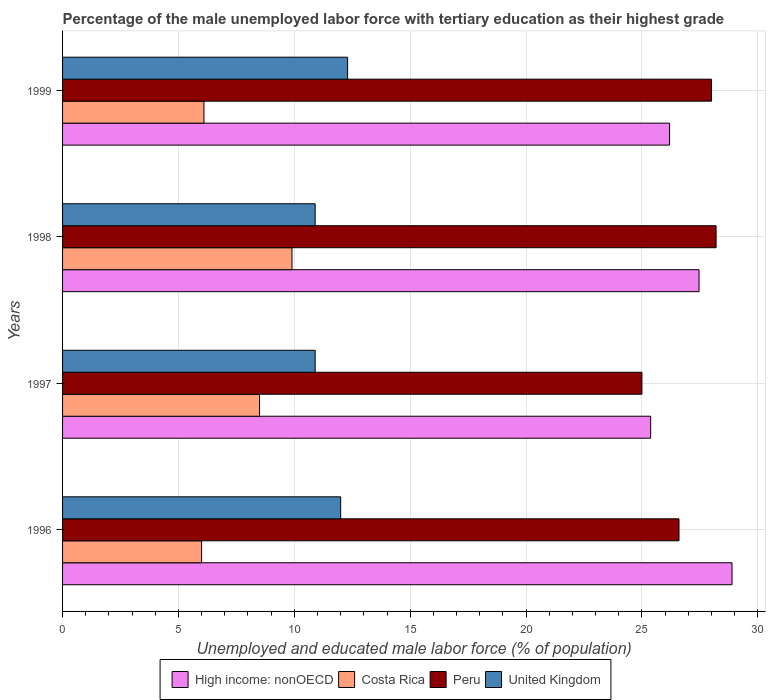How many different coloured bars are there?
Your response must be concise. 4. What is the label of the 1st group of bars from the top?
Offer a very short reply. 1999. In how many cases, is the number of bars for a given year not equal to the number of legend labels?
Your answer should be very brief. 0. What is the percentage of the unemployed male labor force with tertiary education in Costa Rica in 1999?
Give a very brief answer. 6.1. Across all years, what is the maximum percentage of the unemployed male labor force with tertiary education in United Kingdom?
Your response must be concise. 12.3. Across all years, what is the minimum percentage of the unemployed male labor force with tertiary education in United Kingdom?
Make the answer very short. 10.9. In which year was the percentage of the unemployed male labor force with tertiary education in High income: nonOECD maximum?
Make the answer very short. 1996. In which year was the percentage of the unemployed male labor force with tertiary education in Costa Rica minimum?
Offer a very short reply. 1996. What is the total percentage of the unemployed male labor force with tertiary education in High income: nonOECD in the graph?
Your response must be concise. 107.92. What is the difference between the percentage of the unemployed male labor force with tertiary education in Peru in 1998 and that in 1999?
Your answer should be compact. 0.2. What is the difference between the percentage of the unemployed male labor force with tertiary education in Peru in 1996 and the percentage of the unemployed male labor force with tertiary education in United Kingdom in 1998?
Provide a succinct answer. 15.7. What is the average percentage of the unemployed male labor force with tertiary education in High income: nonOECD per year?
Your response must be concise. 26.98. In the year 1997, what is the difference between the percentage of the unemployed male labor force with tertiary education in High income: nonOECD and percentage of the unemployed male labor force with tertiary education in United Kingdom?
Provide a short and direct response. 14.48. In how many years, is the percentage of the unemployed male labor force with tertiary education in Peru greater than 1 %?
Your response must be concise. 4. What is the ratio of the percentage of the unemployed male labor force with tertiary education in High income: nonOECD in 1996 to that in 1997?
Your answer should be compact. 1.14. Is the percentage of the unemployed male labor force with tertiary education in United Kingdom in 1996 less than that in 1997?
Your answer should be compact. No. Is the difference between the percentage of the unemployed male labor force with tertiary education in High income: nonOECD in 1996 and 1998 greater than the difference between the percentage of the unemployed male labor force with tertiary education in United Kingdom in 1996 and 1998?
Provide a succinct answer. Yes. What is the difference between the highest and the second highest percentage of the unemployed male labor force with tertiary education in High income: nonOECD?
Your response must be concise. 1.42. What is the difference between the highest and the lowest percentage of the unemployed male labor force with tertiary education in United Kingdom?
Provide a succinct answer. 1.4. Is the sum of the percentage of the unemployed male labor force with tertiary education in High income: nonOECD in 1997 and 1998 greater than the maximum percentage of the unemployed male labor force with tertiary education in United Kingdom across all years?
Offer a terse response. Yes. What does the 3rd bar from the top in 1997 represents?
Your answer should be very brief. Costa Rica. How many bars are there?
Offer a very short reply. 16. How many years are there in the graph?
Offer a terse response. 4. Does the graph contain any zero values?
Ensure brevity in your answer.  No. How many legend labels are there?
Give a very brief answer. 4. What is the title of the graph?
Provide a succinct answer. Percentage of the male unemployed labor force with tertiary education as their highest grade. What is the label or title of the X-axis?
Your response must be concise. Unemployed and educated male labor force (% of population). What is the label or title of the Y-axis?
Give a very brief answer. Years. What is the Unemployed and educated male labor force (% of population) in High income: nonOECD in 1996?
Ensure brevity in your answer.  28.89. What is the Unemployed and educated male labor force (% of population) in Costa Rica in 1996?
Give a very brief answer. 6. What is the Unemployed and educated male labor force (% of population) of Peru in 1996?
Offer a very short reply. 26.6. What is the Unemployed and educated male labor force (% of population) of United Kingdom in 1996?
Ensure brevity in your answer.  12. What is the Unemployed and educated male labor force (% of population) of High income: nonOECD in 1997?
Give a very brief answer. 25.38. What is the Unemployed and educated male labor force (% of population) in United Kingdom in 1997?
Your answer should be very brief. 10.9. What is the Unemployed and educated male labor force (% of population) in High income: nonOECD in 1998?
Provide a succinct answer. 27.46. What is the Unemployed and educated male labor force (% of population) in Costa Rica in 1998?
Your response must be concise. 9.9. What is the Unemployed and educated male labor force (% of population) of Peru in 1998?
Ensure brevity in your answer.  28.2. What is the Unemployed and educated male labor force (% of population) in United Kingdom in 1998?
Provide a short and direct response. 10.9. What is the Unemployed and educated male labor force (% of population) of High income: nonOECD in 1999?
Make the answer very short. 26.19. What is the Unemployed and educated male labor force (% of population) of Costa Rica in 1999?
Your answer should be very brief. 6.1. What is the Unemployed and educated male labor force (% of population) of Peru in 1999?
Offer a very short reply. 28. What is the Unemployed and educated male labor force (% of population) in United Kingdom in 1999?
Keep it short and to the point. 12.3. Across all years, what is the maximum Unemployed and educated male labor force (% of population) of High income: nonOECD?
Your answer should be very brief. 28.89. Across all years, what is the maximum Unemployed and educated male labor force (% of population) of Costa Rica?
Ensure brevity in your answer.  9.9. Across all years, what is the maximum Unemployed and educated male labor force (% of population) in Peru?
Make the answer very short. 28.2. Across all years, what is the maximum Unemployed and educated male labor force (% of population) of United Kingdom?
Offer a terse response. 12.3. Across all years, what is the minimum Unemployed and educated male labor force (% of population) of High income: nonOECD?
Give a very brief answer. 25.38. Across all years, what is the minimum Unemployed and educated male labor force (% of population) of Peru?
Offer a very short reply. 25. Across all years, what is the minimum Unemployed and educated male labor force (% of population) in United Kingdom?
Provide a succinct answer. 10.9. What is the total Unemployed and educated male labor force (% of population) in High income: nonOECD in the graph?
Your answer should be very brief. 107.92. What is the total Unemployed and educated male labor force (% of population) in Costa Rica in the graph?
Provide a succinct answer. 30.5. What is the total Unemployed and educated male labor force (% of population) in Peru in the graph?
Make the answer very short. 107.8. What is the total Unemployed and educated male labor force (% of population) in United Kingdom in the graph?
Keep it short and to the point. 46.1. What is the difference between the Unemployed and educated male labor force (% of population) in High income: nonOECD in 1996 and that in 1997?
Your answer should be very brief. 3.51. What is the difference between the Unemployed and educated male labor force (% of population) in Costa Rica in 1996 and that in 1997?
Your response must be concise. -2.5. What is the difference between the Unemployed and educated male labor force (% of population) in Peru in 1996 and that in 1997?
Make the answer very short. 1.6. What is the difference between the Unemployed and educated male labor force (% of population) of High income: nonOECD in 1996 and that in 1998?
Keep it short and to the point. 1.42. What is the difference between the Unemployed and educated male labor force (% of population) of Costa Rica in 1996 and that in 1998?
Your answer should be compact. -3.9. What is the difference between the Unemployed and educated male labor force (% of population) in High income: nonOECD in 1996 and that in 1999?
Give a very brief answer. 2.69. What is the difference between the Unemployed and educated male labor force (% of population) of Costa Rica in 1996 and that in 1999?
Make the answer very short. -0.1. What is the difference between the Unemployed and educated male labor force (% of population) in Peru in 1996 and that in 1999?
Make the answer very short. -1.4. What is the difference between the Unemployed and educated male labor force (% of population) of High income: nonOECD in 1997 and that in 1998?
Provide a short and direct response. -2.09. What is the difference between the Unemployed and educated male labor force (% of population) of Costa Rica in 1997 and that in 1998?
Your answer should be compact. -1.4. What is the difference between the Unemployed and educated male labor force (% of population) of High income: nonOECD in 1997 and that in 1999?
Keep it short and to the point. -0.82. What is the difference between the Unemployed and educated male labor force (% of population) of Peru in 1997 and that in 1999?
Provide a succinct answer. -3. What is the difference between the Unemployed and educated male labor force (% of population) in United Kingdom in 1997 and that in 1999?
Your answer should be very brief. -1.4. What is the difference between the Unemployed and educated male labor force (% of population) in High income: nonOECD in 1998 and that in 1999?
Provide a succinct answer. 1.27. What is the difference between the Unemployed and educated male labor force (% of population) in Costa Rica in 1998 and that in 1999?
Give a very brief answer. 3.8. What is the difference between the Unemployed and educated male labor force (% of population) of United Kingdom in 1998 and that in 1999?
Give a very brief answer. -1.4. What is the difference between the Unemployed and educated male labor force (% of population) in High income: nonOECD in 1996 and the Unemployed and educated male labor force (% of population) in Costa Rica in 1997?
Your answer should be very brief. 20.39. What is the difference between the Unemployed and educated male labor force (% of population) of High income: nonOECD in 1996 and the Unemployed and educated male labor force (% of population) of Peru in 1997?
Provide a succinct answer. 3.89. What is the difference between the Unemployed and educated male labor force (% of population) of High income: nonOECD in 1996 and the Unemployed and educated male labor force (% of population) of United Kingdom in 1997?
Offer a terse response. 17.99. What is the difference between the Unemployed and educated male labor force (% of population) of Costa Rica in 1996 and the Unemployed and educated male labor force (% of population) of Peru in 1997?
Provide a short and direct response. -19. What is the difference between the Unemployed and educated male labor force (% of population) in High income: nonOECD in 1996 and the Unemployed and educated male labor force (% of population) in Costa Rica in 1998?
Make the answer very short. 18.99. What is the difference between the Unemployed and educated male labor force (% of population) in High income: nonOECD in 1996 and the Unemployed and educated male labor force (% of population) in Peru in 1998?
Provide a short and direct response. 0.69. What is the difference between the Unemployed and educated male labor force (% of population) of High income: nonOECD in 1996 and the Unemployed and educated male labor force (% of population) of United Kingdom in 1998?
Keep it short and to the point. 17.99. What is the difference between the Unemployed and educated male labor force (% of population) of Costa Rica in 1996 and the Unemployed and educated male labor force (% of population) of Peru in 1998?
Your response must be concise. -22.2. What is the difference between the Unemployed and educated male labor force (% of population) of Costa Rica in 1996 and the Unemployed and educated male labor force (% of population) of United Kingdom in 1998?
Provide a short and direct response. -4.9. What is the difference between the Unemployed and educated male labor force (% of population) of High income: nonOECD in 1996 and the Unemployed and educated male labor force (% of population) of Costa Rica in 1999?
Your answer should be compact. 22.79. What is the difference between the Unemployed and educated male labor force (% of population) in High income: nonOECD in 1996 and the Unemployed and educated male labor force (% of population) in Peru in 1999?
Provide a succinct answer. 0.89. What is the difference between the Unemployed and educated male labor force (% of population) in High income: nonOECD in 1996 and the Unemployed and educated male labor force (% of population) in United Kingdom in 1999?
Provide a succinct answer. 16.59. What is the difference between the Unemployed and educated male labor force (% of population) in Costa Rica in 1996 and the Unemployed and educated male labor force (% of population) in Peru in 1999?
Your answer should be compact. -22. What is the difference between the Unemployed and educated male labor force (% of population) in Costa Rica in 1996 and the Unemployed and educated male labor force (% of population) in United Kingdom in 1999?
Your answer should be compact. -6.3. What is the difference between the Unemployed and educated male labor force (% of population) in High income: nonOECD in 1997 and the Unemployed and educated male labor force (% of population) in Costa Rica in 1998?
Offer a very short reply. 15.48. What is the difference between the Unemployed and educated male labor force (% of population) of High income: nonOECD in 1997 and the Unemployed and educated male labor force (% of population) of Peru in 1998?
Give a very brief answer. -2.82. What is the difference between the Unemployed and educated male labor force (% of population) of High income: nonOECD in 1997 and the Unemployed and educated male labor force (% of population) of United Kingdom in 1998?
Make the answer very short. 14.48. What is the difference between the Unemployed and educated male labor force (% of population) of Costa Rica in 1997 and the Unemployed and educated male labor force (% of population) of Peru in 1998?
Offer a terse response. -19.7. What is the difference between the Unemployed and educated male labor force (% of population) in High income: nonOECD in 1997 and the Unemployed and educated male labor force (% of population) in Costa Rica in 1999?
Provide a short and direct response. 19.28. What is the difference between the Unemployed and educated male labor force (% of population) of High income: nonOECD in 1997 and the Unemployed and educated male labor force (% of population) of Peru in 1999?
Ensure brevity in your answer.  -2.62. What is the difference between the Unemployed and educated male labor force (% of population) in High income: nonOECD in 1997 and the Unemployed and educated male labor force (% of population) in United Kingdom in 1999?
Your answer should be very brief. 13.08. What is the difference between the Unemployed and educated male labor force (% of population) in Costa Rica in 1997 and the Unemployed and educated male labor force (% of population) in Peru in 1999?
Offer a terse response. -19.5. What is the difference between the Unemployed and educated male labor force (% of population) of Peru in 1997 and the Unemployed and educated male labor force (% of population) of United Kingdom in 1999?
Offer a very short reply. 12.7. What is the difference between the Unemployed and educated male labor force (% of population) of High income: nonOECD in 1998 and the Unemployed and educated male labor force (% of population) of Costa Rica in 1999?
Your response must be concise. 21.36. What is the difference between the Unemployed and educated male labor force (% of population) in High income: nonOECD in 1998 and the Unemployed and educated male labor force (% of population) in Peru in 1999?
Your response must be concise. -0.54. What is the difference between the Unemployed and educated male labor force (% of population) in High income: nonOECD in 1998 and the Unemployed and educated male labor force (% of population) in United Kingdom in 1999?
Provide a succinct answer. 15.16. What is the difference between the Unemployed and educated male labor force (% of population) in Costa Rica in 1998 and the Unemployed and educated male labor force (% of population) in Peru in 1999?
Give a very brief answer. -18.1. What is the difference between the Unemployed and educated male labor force (% of population) in Costa Rica in 1998 and the Unemployed and educated male labor force (% of population) in United Kingdom in 1999?
Your answer should be compact. -2.4. What is the average Unemployed and educated male labor force (% of population) of High income: nonOECD per year?
Offer a terse response. 26.98. What is the average Unemployed and educated male labor force (% of population) of Costa Rica per year?
Your answer should be compact. 7.62. What is the average Unemployed and educated male labor force (% of population) of Peru per year?
Offer a very short reply. 26.95. What is the average Unemployed and educated male labor force (% of population) of United Kingdom per year?
Your response must be concise. 11.53. In the year 1996, what is the difference between the Unemployed and educated male labor force (% of population) in High income: nonOECD and Unemployed and educated male labor force (% of population) in Costa Rica?
Your answer should be very brief. 22.89. In the year 1996, what is the difference between the Unemployed and educated male labor force (% of population) of High income: nonOECD and Unemployed and educated male labor force (% of population) of Peru?
Your answer should be compact. 2.29. In the year 1996, what is the difference between the Unemployed and educated male labor force (% of population) of High income: nonOECD and Unemployed and educated male labor force (% of population) of United Kingdom?
Ensure brevity in your answer.  16.89. In the year 1996, what is the difference between the Unemployed and educated male labor force (% of population) of Costa Rica and Unemployed and educated male labor force (% of population) of Peru?
Your answer should be very brief. -20.6. In the year 1996, what is the difference between the Unemployed and educated male labor force (% of population) in Costa Rica and Unemployed and educated male labor force (% of population) in United Kingdom?
Offer a terse response. -6. In the year 1996, what is the difference between the Unemployed and educated male labor force (% of population) of Peru and Unemployed and educated male labor force (% of population) of United Kingdom?
Offer a terse response. 14.6. In the year 1997, what is the difference between the Unemployed and educated male labor force (% of population) in High income: nonOECD and Unemployed and educated male labor force (% of population) in Costa Rica?
Provide a short and direct response. 16.88. In the year 1997, what is the difference between the Unemployed and educated male labor force (% of population) in High income: nonOECD and Unemployed and educated male labor force (% of population) in Peru?
Your answer should be very brief. 0.38. In the year 1997, what is the difference between the Unemployed and educated male labor force (% of population) of High income: nonOECD and Unemployed and educated male labor force (% of population) of United Kingdom?
Offer a very short reply. 14.48. In the year 1997, what is the difference between the Unemployed and educated male labor force (% of population) of Costa Rica and Unemployed and educated male labor force (% of population) of Peru?
Provide a short and direct response. -16.5. In the year 1997, what is the difference between the Unemployed and educated male labor force (% of population) in Costa Rica and Unemployed and educated male labor force (% of population) in United Kingdom?
Provide a succinct answer. -2.4. In the year 1998, what is the difference between the Unemployed and educated male labor force (% of population) in High income: nonOECD and Unemployed and educated male labor force (% of population) in Costa Rica?
Provide a short and direct response. 17.56. In the year 1998, what is the difference between the Unemployed and educated male labor force (% of population) in High income: nonOECD and Unemployed and educated male labor force (% of population) in Peru?
Make the answer very short. -0.74. In the year 1998, what is the difference between the Unemployed and educated male labor force (% of population) of High income: nonOECD and Unemployed and educated male labor force (% of population) of United Kingdom?
Your answer should be compact. 16.56. In the year 1998, what is the difference between the Unemployed and educated male labor force (% of population) of Costa Rica and Unemployed and educated male labor force (% of population) of Peru?
Provide a succinct answer. -18.3. In the year 1998, what is the difference between the Unemployed and educated male labor force (% of population) of Costa Rica and Unemployed and educated male labor force (% of population) of United Kingdom?
Provide a succinct answer. -1. In the year 1998, what is the difference between the Unemployed and educated male labor force (% of population) of Peru and Unemployed and educated male labor force (% of population) of United Kingdom?
Make the answer very short. 17.3. In the year 1999, what is the difference between the Unemployed and educated male labor force (% of population) in High income: nonOECD and Unemployed and educated male labor force (% of population) in Costa Rica?
Your response must be concise. 20.09. In the year 1999, what is the difference between the Unemployed and educated male labor force (% of population) of High income: nonOECD and Unemployed and educated male labor force (% of population) of Peru?
Give a very brief answer. -1.81. In the year 1999, what is the difference between the Unemployed and educated male labor force (% of population) of High income: nonOECD and Unemployed and educated male labor force (% of population) of United Kingdom?
Make the answer very short. 13.89. In the year 1999, what is the difference between the Unemployed and educated male labor force (% of population) of Costa Rica and Unemployed and educated male labor force (% of population) of Peru?
Your response must be concise. -21.9. In the year 1999, what is the difference between the Unemployed and educated male labor force (% of population) in Costa Rica and Unemployed and educated male labor force (% of population) in United Kingdom?
Ensure brevity in your answer.  -6.2. In the year 1999, what is the difference between the Unemployed and educated male labor force (% of population) in Peru and Unemployed and educated male labor force (% of population) in United Kingdom?
Provide a succinct answer. 15.7. What is the ratio of the Unemployed and educated male labor force (% of population) of High income: nonOECD in 1996 to that in 1997?
Give a very brief answer. 1.14. What is the ratio of the Unemployed and educated male labor force (% of population) in Costa Rica in 1996 to that in 1997?
Your response must be concise. 0.71. What is the ratio of the Unemployed and educated male labor force (% of population) of Peru in 1996 to that in 1997?
Offer a terse response. 1.06. What is the ratio of the Unemployed and educated male labor force (% of population) in United Kingdom in 1996 to that in 1997?
Make the answer very short. 1.1. What is the ratio of the Unemployed and educated male labor force (% of population) of High income: nonOECD in 1996 to that in 1998?
Offer a very short reply. 1.05. What is the ratio of the Unemployed and educated male labor force (% of population) in Costa Rica in 1996 to that in 1998?
Give a very brief answer. 0.61. What is the ratio of the Unemployed and educated male labor force (% of population) in Peru in 1996 to that in 1998?
Give a very brief answer. 0.94. What is the ratio of the Unemployed and educated male labor force (% of population) of United Kingdom in 1996 to that in 1998?
Offer a terse response. 1.1. What is the ratio of the Unemployed and educated male labor force (% of population) in High income: nonOECD in 1996 to that in 1999?
Offer a terse response. 1.1. What is the ratio of the Unemployed and educated male labor force (% of population) in Costa Rica in 1996 to that in 1999?
Your response must be concise. 0.98. What is the ratio of the Unemployed and educated male labor force (% of population) of United Kingdom in 1996 to that in 1999?
Offer a terse response. 0.98. What is the ratio of the Unemployed and educated male labor force (% of population) of High income: nonOECD in 1997 to that in 1998?
Offer a very short reply. 0.92. What is the ratio of the Unemployed and educated male labor force (% of population) of Costa Rica in 1997 to that in 1998?
Offer a terse response. 0.86. What is the ratio of the Unemployed and educated male labor force (% of population) in Peru in 1997 to that in 1998?
Keep it short and to the point. 0.89. What is the ratio of the Unemployed and educated male labor force (% of population) in United Kingdom in 1997 to that in 1998?
Give a very brief answer. 1. What is the ratio of the Unemployed and educated male labor force (% of population) in High income: nonOECD in 1997 to that in 1999?
Make the answer very short. 0.97. What is the ratio of the Unemployed and educated male labor force (% of population) in Costa Rica in 1997 to that in 1999?
Give a very brief answer. 1.39. What is the ratio of the Unemployed and educated male labor force (% of population) of Peru in 1997 to that in 1999?
Provide a short and direct response. 0.89. What is the ratio of the Unemployed and educated male labor force (% of population) of United Kingdom in 1997 to that in 1999?
Provide a succinct answer. 0.89. What is the ratio of the Unemployed and educated male labor force (% of population) of High income: nonOECD in 1998 to that in 1999?
Provide a succinct answer. 1.05. What is the ratio of the Unemployed and educated male labor force (% of population) of Costa Rica in 1998 to that in 1999?
Keep it short and to the point. 1.62. What is the ratio of the Unemployed and educated male labor force (% of population) of Peru in 1998 to that in 1999?
Your response must be concise. 1.01. What is the ratio of the Unemployed and educated male labor force (% of population) in United Kingdom in 1998 to that in 1999?
Your answer should be very brief. 0.89. What is the difference between the highest and the second highest Unemployed and educated male labor force (% of population) in High income: nonOECD?
Offer a very short reply. 1.42. What is the difference between the highest and the lowest Unemployed and educated male labor force (% of population) in High income: nonOECD?
Your answer should be compact. 3.51. What is the difference between the highest and the lowest Unemployed and educated male labor force (% of population) in Costa Rica?
Provide a short and direct response. 3.9. What is the difference between the highest and the lowest Unemployed and educated male labor force (% of population) of Peru?
Offer a terse response. 3.2. What is the difference between the highest and the lowest Unemployed and educated male labor force (% of population) in United Kingdom?
Provide a succinct answer. 1.4. 